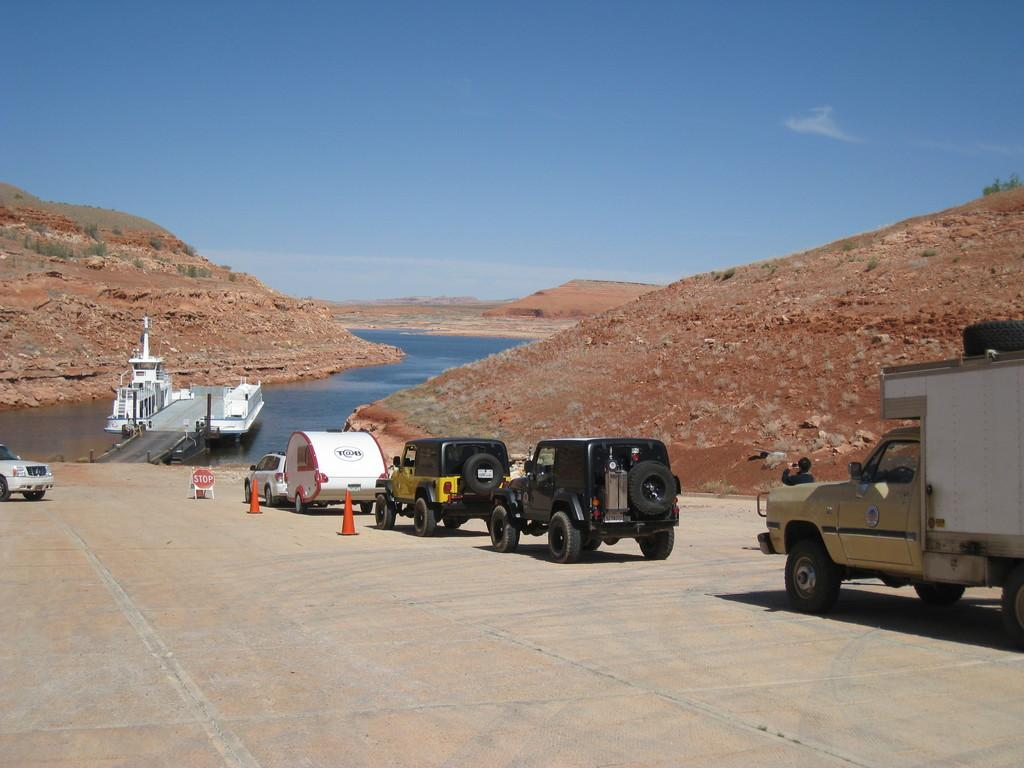What can be seen on the right side of the image? There are vehicles on the right side of the image. What is located in the middle of the image? There is water in the middle of the image. What type of landscape feature is present on both sides of the image? There are hills on either side of the image. What is visible at the top of the image? The sky is visible at the top of the image. What type of rule is being enforced by the kitten in the image? There is no kitten present in the image, and therefore no rule enforcement can be observed. What type of glass is being used to drink the water in the image? There is no glass present in the image; the water is not being consumed. 